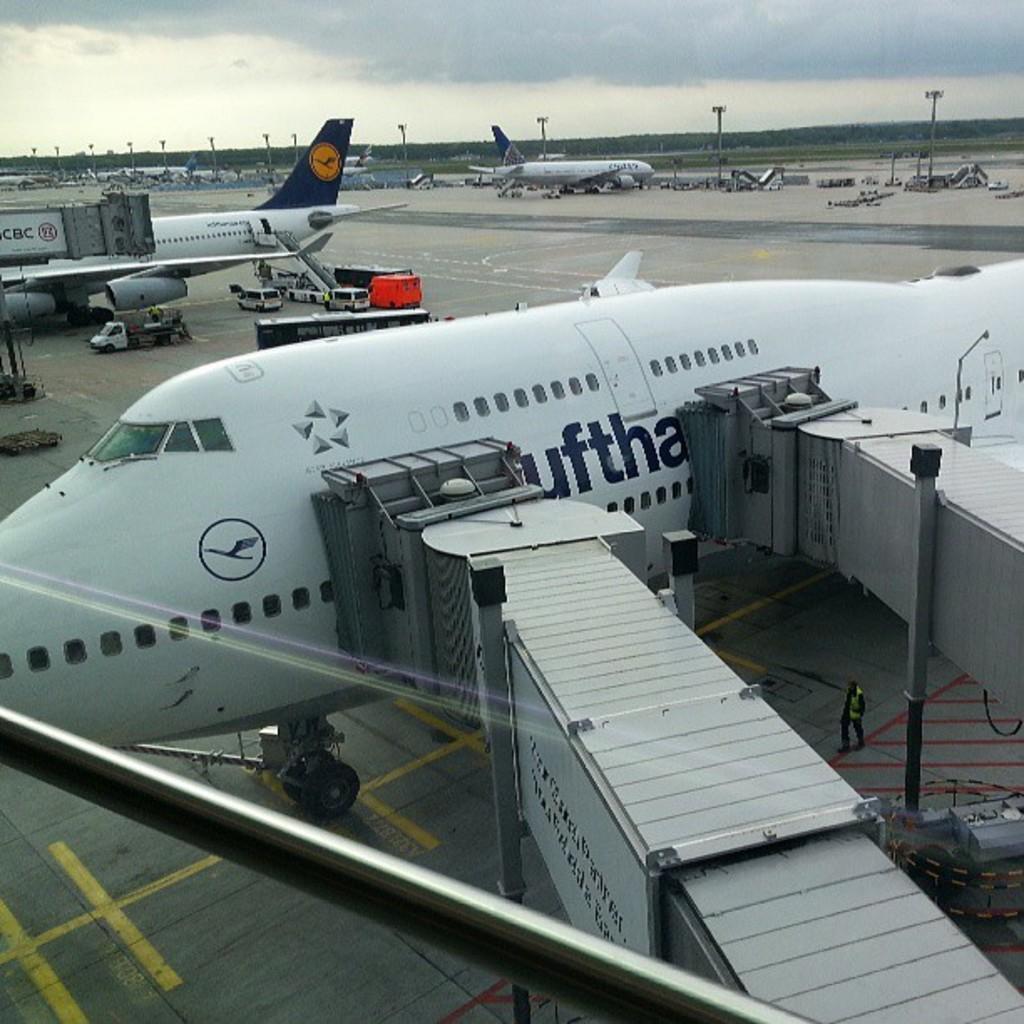Describe this image in one or two sentences. In this image there are some airplanes and at the bottom there are some vehicles machines and some persons are walking. And in the background there are some poles and vehicles, trees and mountains. And in the center there are some vehicles and a road on the top of the image there is sky. 